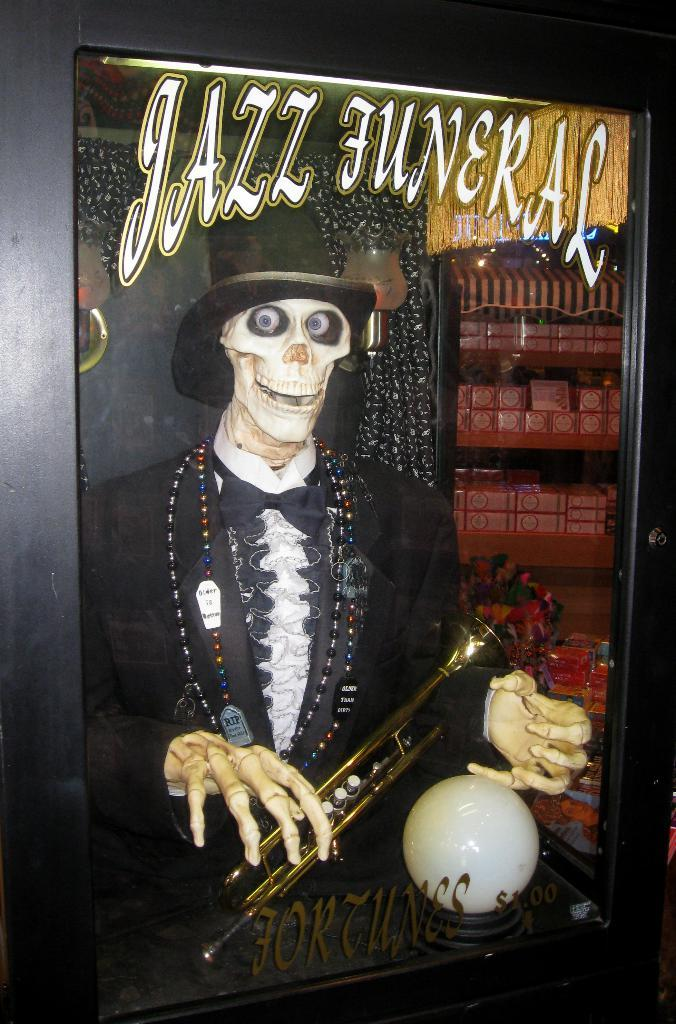What is the main object in the image? There is a frame in the image. What can be seen inside the frame? Inside the frame, there is a skeleton person. What is the skeleton person wearing? The skeleton person is wearing a cap. What is the skeleton person holding? The skeleton person is holding an instrument. What type of learning system is being used by the tank in the image? There is no tank present in the image, and therefore no learning system can be associated with it. 